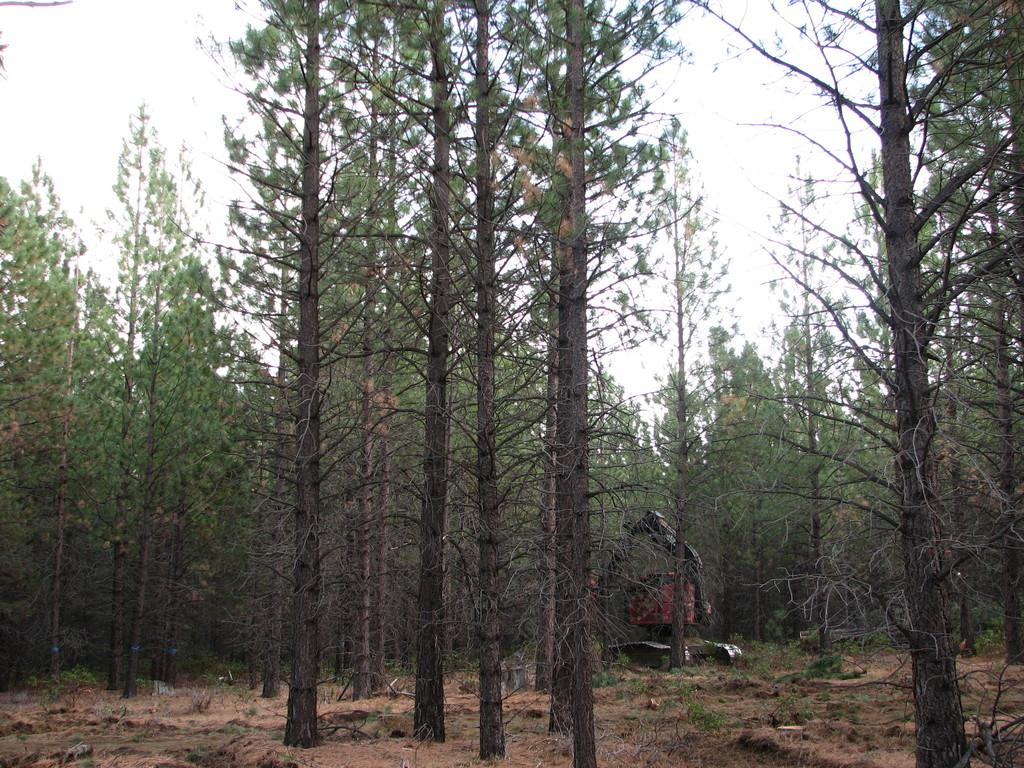What type of natural elements can be seen in the image? There are trees in the image. What man-made object is present on the ground in the image? There appears to be a machine on the ground in the image. How would you describe the weather in the image? The sky is cloudy in the image. What type of brick structure can be seen in the image? There is no brick structure present in the image. Is there a porter carrying luggage in the image? There is no porter or luggage present in the image. 